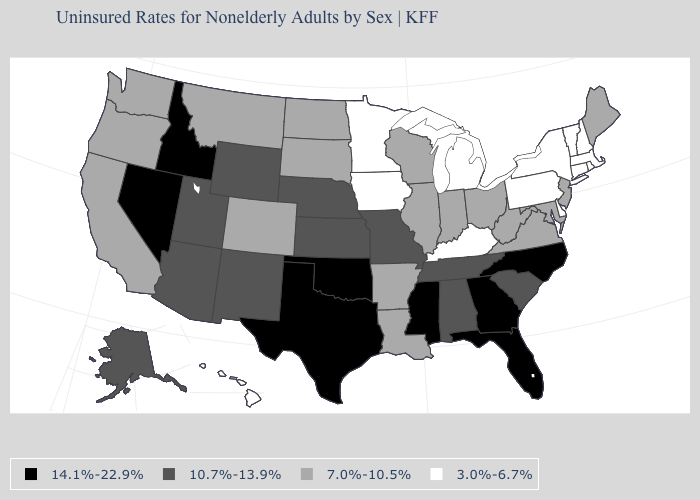Name the states that have a value in the range 7.0%-10.5%?
Be succinct. Arkansas, California, Colorado, Illinois, Indiana, Louisiana, Maine, Maryland, Montana, New Jersey, North Dakota, Ohio, Oregon, South Dakota, Virginia, Washington, West Virginia, Wisconsin. What is the lowest value in states that border South Carolina?
Quick response, please. 14.1%-22.9%. What is the value of Ohio?
Concise answer only. 7.0%-10.5%. Name the states that have a value in the range 14.1%-22.9%?
Give a very brief answer. Florida, Georgia, Idaho, Mississippi, Nevada, North Carolina, Oklahoma, Texas. Does Pennsylvania have a higher value than Indiana?
Answer briefly. No. How many symbols are there in the legend?
Be succinct. 4. Name the states that have a value in the range 14.1%-22.9%?
Concise answer only. Florida, Georgia, Idaho, Mississippi, Nevada, North Carolina, Oklahoma, Texas. Among the states that border Florida , which have the highest value?
Be succinct. Georgia. What is the highest value in the Northeast ?
Answer briefly. 7.0%-10.5%. What is the value of Mississippi?
Quick response, please. 14.1%-22.9%. Name the states that have a value in the range 14.1%-22.9%?
Answer briefly. Florida, Georgia, Idaho, Mississippi, Nevada, North Carolina, Oklahoma, Texas. What is the value of Massachusetts?
Quick response, please. 3.0%-6.7%. What is the value of Pennsylvania?
Short answer required. 3.0%-6.7%. Name the states that have a value in the range 3.0%-6.7%?
Quick response, please. Connecticut, Delaware, Hawaii, Iowa, Kentucky, Massachusetts, Michigan, Minnesota, New Hampshire, New York, Pennsylvania, Rhode Island, Vermont. 